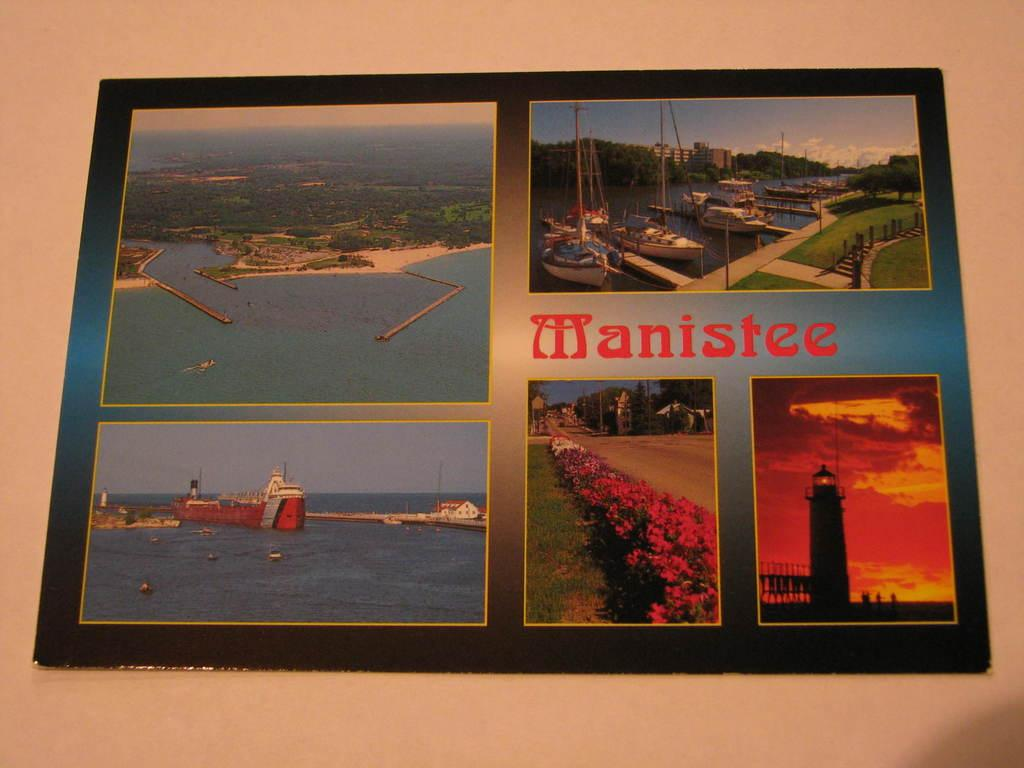What object in the image contains multiple images? The photo frame in the image contains five images. What can be seen in the background of the image? There is water, trees, and a ship visible in the image. What type of flora is present in the image? There are flowers in the image. How many snails can be seen crawling on the flowers in the image? There are no snails visible in the image; it only features flowers. What type of geese are swimming in the water in the image? There are no geese present in the image; it only features water, trees, and a ship. 